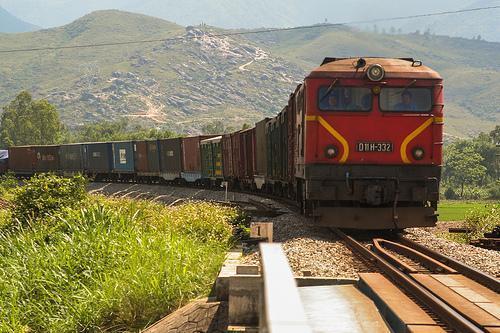How many trains are there?
Give a very brief answer. 1. 